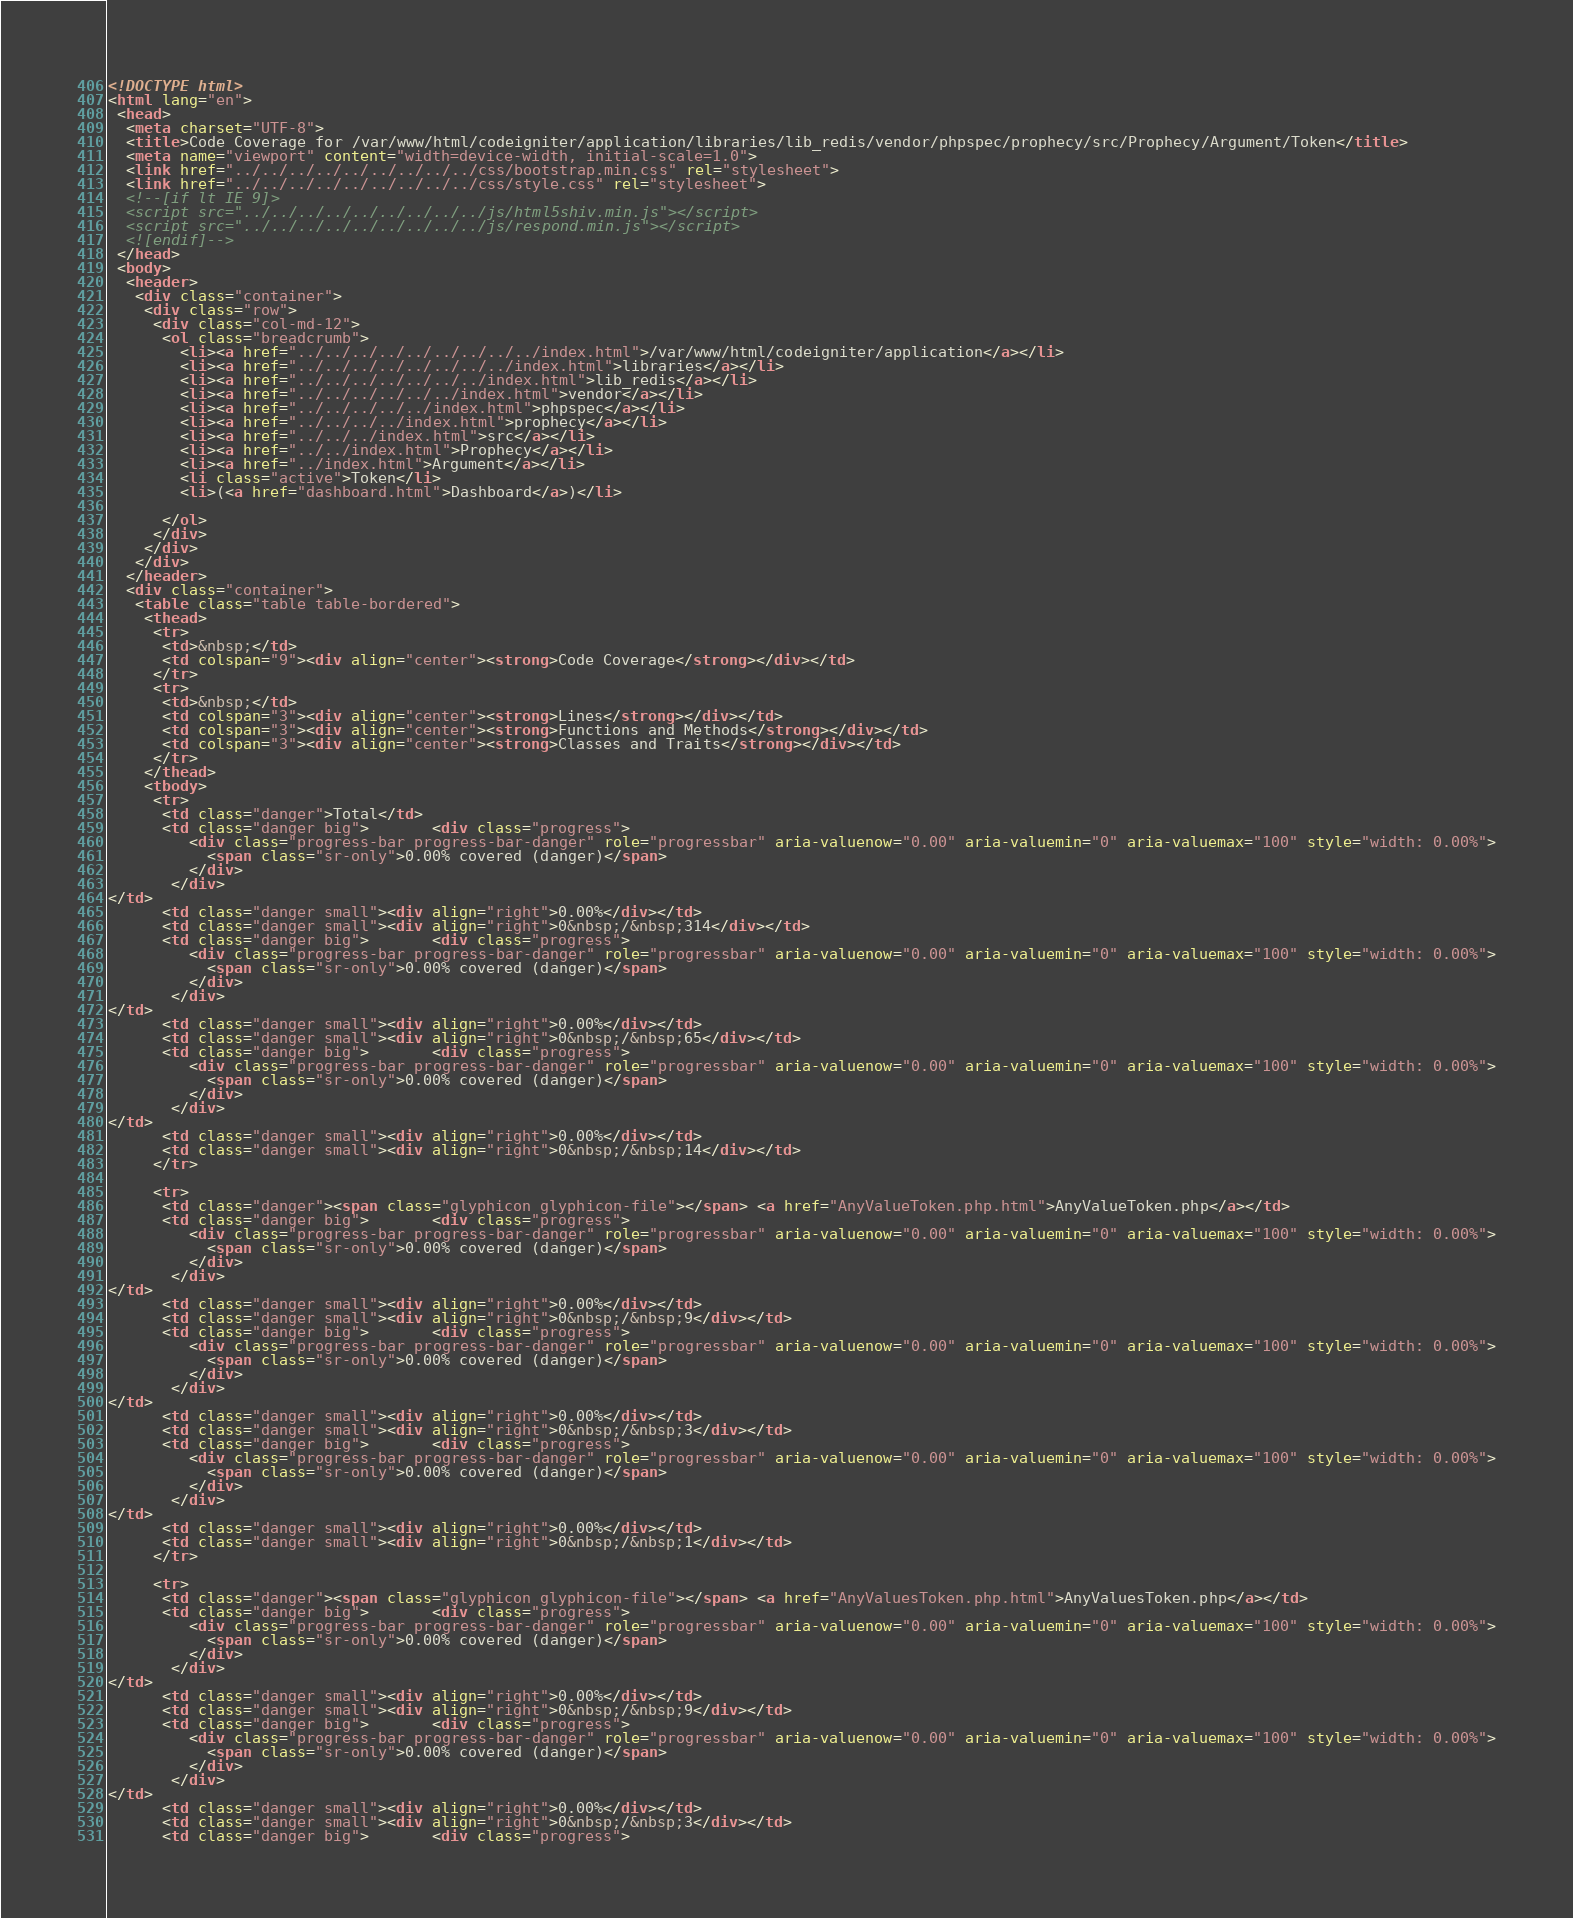Convert code to text. <code><loc_0><loc_0><loc_500><loc_500><_HTML_><!DOCTYPE html>
<html lang="en">
 <head>
  <meta charset="UTF-8">
  <title>Code Coverage for /var/www/html/codeigniter/application/libraries/lib_redis/vendor/phpspec/prophecy/src/Prophecy/Argument/Token</title>
  <meta name="viewport" content="width=device-width, initial-scale=1.0">
  <link href="../../../../../../../../../css/bootstrap.min.css" rel="stylesheet">
  <link href="../../../../../../../../../css/style.css" rel="stylesheet">
  <!--[if lt IE 9]>
  <script src="../../../../../../../../../js/html5shiv.min.js"></script>
  <script src="../../../../../../../../../js/respond.min.js"></script>
  <![endif]-->
 </head>
 <body>
  <header>
   <div class="container">
    <div class="row">
     <div class="col-md-12">
      <ol class="breadcrumb">
        <li><a href="../../../../../../../../../index.html">/var/www/html/codeigniter/application</a></li>
        <li><a href="../../../../../../../../index.html">libraries</a></li>
        <li><a href="../../../../../../../index.html">lib_redis</a></li>
        <li><a href="../../../../../../index.html">vendor</a></li>
        <li><a href="../../../../../index.html">phpspec</a></li>
        <li><a href="../../../../index.html">prophecy</a></li>
        <li><a href="../../../index.html">src</a></li>
        <li><a href="../../index.html">Prophecy</a></li>
        <li><a href="../index.html">Argument</a></li>
        <li class="active">Token</li>
        <li>(<a href="dashboard.html">Dashboard</a>)</li>

      </ol>
     </div>
    </div>
   </div>
  </header>
  <div class="container">
   <table class="table table-bordered">
    <thead>
     <tr>
      <td>&nbsp;</td>
      <td colspan="9"><div align="center"><strong>Code Coverage</strong></div></td>
     </tr>
     <tr>
      <td>&nbsp;</td>
      <td colspan="3"><div align="center"><strong>Lines</strong></div></td>
      <td colspan="3"><div align="center"><strong>Functions and Methods</strong></div></td>
      <td colspan="3"><div align="center"><strong>Classes and Traits</strong></div></td>
     </tr>
    </thead>
    <tbody>
     <tr>
      <td class="danger">Total</td>
      <td class="danger big">       <div class="progress">
         <div class="progress-bar progress-bar-danger" role="progressbar" aria-valuenow="0.00" aria-valuemin="0" aria-valuemax="100" style="width: 0.00%">
           <span class="sr-only">0.00% covered (danger)</span>
         </div>
       </div>
</td>
      <td class="danger small"><div align="right">0.00%</div></td>
      <td class="danger small"><div align="right">0&nbsp;/&nbsp;314</div></td>
      <td class="danger big">       <div class="progress">
         <div class="progress-bar progress-bar-danger" role="progressbar" aria-valuenow="0.00" aria-valuemin="0" aria-valuemax="100" style="width: 0.00%">
           <span class="sr-only">0.00% covered (danger)</span>
         </div>
       </div>
</td>
      <td class="danger small"><div align="right">0.00%</div></td>
      <td class="danger small"><div align="right">0&nbsp;/&nbsp;65</div></td>
      <td class="danger big">       <div class="progress">
         <div class="progress-bar progress-bar-danger" role="progressbar" aria-valuenow="0.00" aria-valuemin="0" aria-valuemax="100" style="width: 0.00%">
           <span class="sr-only">0.00% covered (danger)</span>
         </div>
       </div>
</td>
      <td class="danger small"><div align="right">0.00%</div></td>
      <td class="danger small"><div align="right">0&nbsp;/&nbsp;14</div></td>
     </tr>

     <tr>
      <td class="danger"><span class="glyphicon glyphicon-file"></span> <a href="AnyValueToken.php.html">AnyValueToken.php</a></td>
      <td class="danger big">       <div class="progress">
         <div class="progress-bar progress-bar-danger" role="progressbar" aria-valuenow="0.00" aria-valuemin="0" aria-valuemax="100" style="width: 0.00%">
           <span class="sr-only">0.00% covered (danger)</span>
         </div>
       </div>
</td>
      <td class="danger small"><div align="right">0.00%</div></td>
      <td class="danger small"><div align="right">0&nbsp;/&nbsp;9</div></td>
      <td class="danger big">       <div class="progress">
         <div class="progress-bar progress-bar-danger" role="progressbar" aria-valuenow="0.00" aria-valuemin="0" aria-valuemax="100" style="width: 0.00%">
           <span class="sr-only">0.00% covered (danger)</span>
         </div>
       </div>
</td>
      <td class="danger small"><div align="right">0.00%</div></td>
      <td class="danger small"><div align="right">0&nbsp;/&nbsp;3</div></td>
      <td class="danger big">       <div class="progress">
         <div class="progress-bar progress-bar-danger" role="progressbar" aria-valuenow="0.00" aria-valuemin="0" aria-valuemax="100" style="width: 0.00%">
           <span class="sr-only">0.00% covered (danger)</span>
         </div>
       </div>
</td>
      <td class="danger small"><div align="right">0.00%</div></td>
      <td class="danger small"><div align="right">0&nbsp;/&nbsp;1</div></td>
     </tr>

     <tr>
      <td class="danger"><span class="glyphicon glyphicon-file"></span> <a href="AnyValuesToken.php.html">AnyValuesToken.php</a></td>
      <td class="danger big">       <div class="progress">
         <div class="progress-bar progress-bar-danger" role="progressbar" aria-valuenow="0.00" aria-valuemin="0" aria-valuemax="100" style="width: 0.00%">
           <span class="sr-only">0.00% covered (danger)</span>
         </div>
       </div>
</td>
      <td class="danger small"><div align="right">0.00%</div></td>
      <td class="danger small"><div align="right">0&nbsp;/&nbsp;9</div></td>
      <td class="danger big">       <div class="progress">
         <div class="progress-bar progress-bar-danger" role="progressbar" aria-valuenow="0.00" aria-valuemin="0" aria-valuemax="100" style="width: 0.00%">
           <span class="sr-only">0.00% covered (danger)</span>
         </div>
       </div>
</td>
      <td class="danger small"><div align="right">0.00%</div></td>
      <td class="danger small"><div align="right">0&nbsp;/&nbsp;3</div></td>
      <td class="danger big">       <div class="progress"></code> 